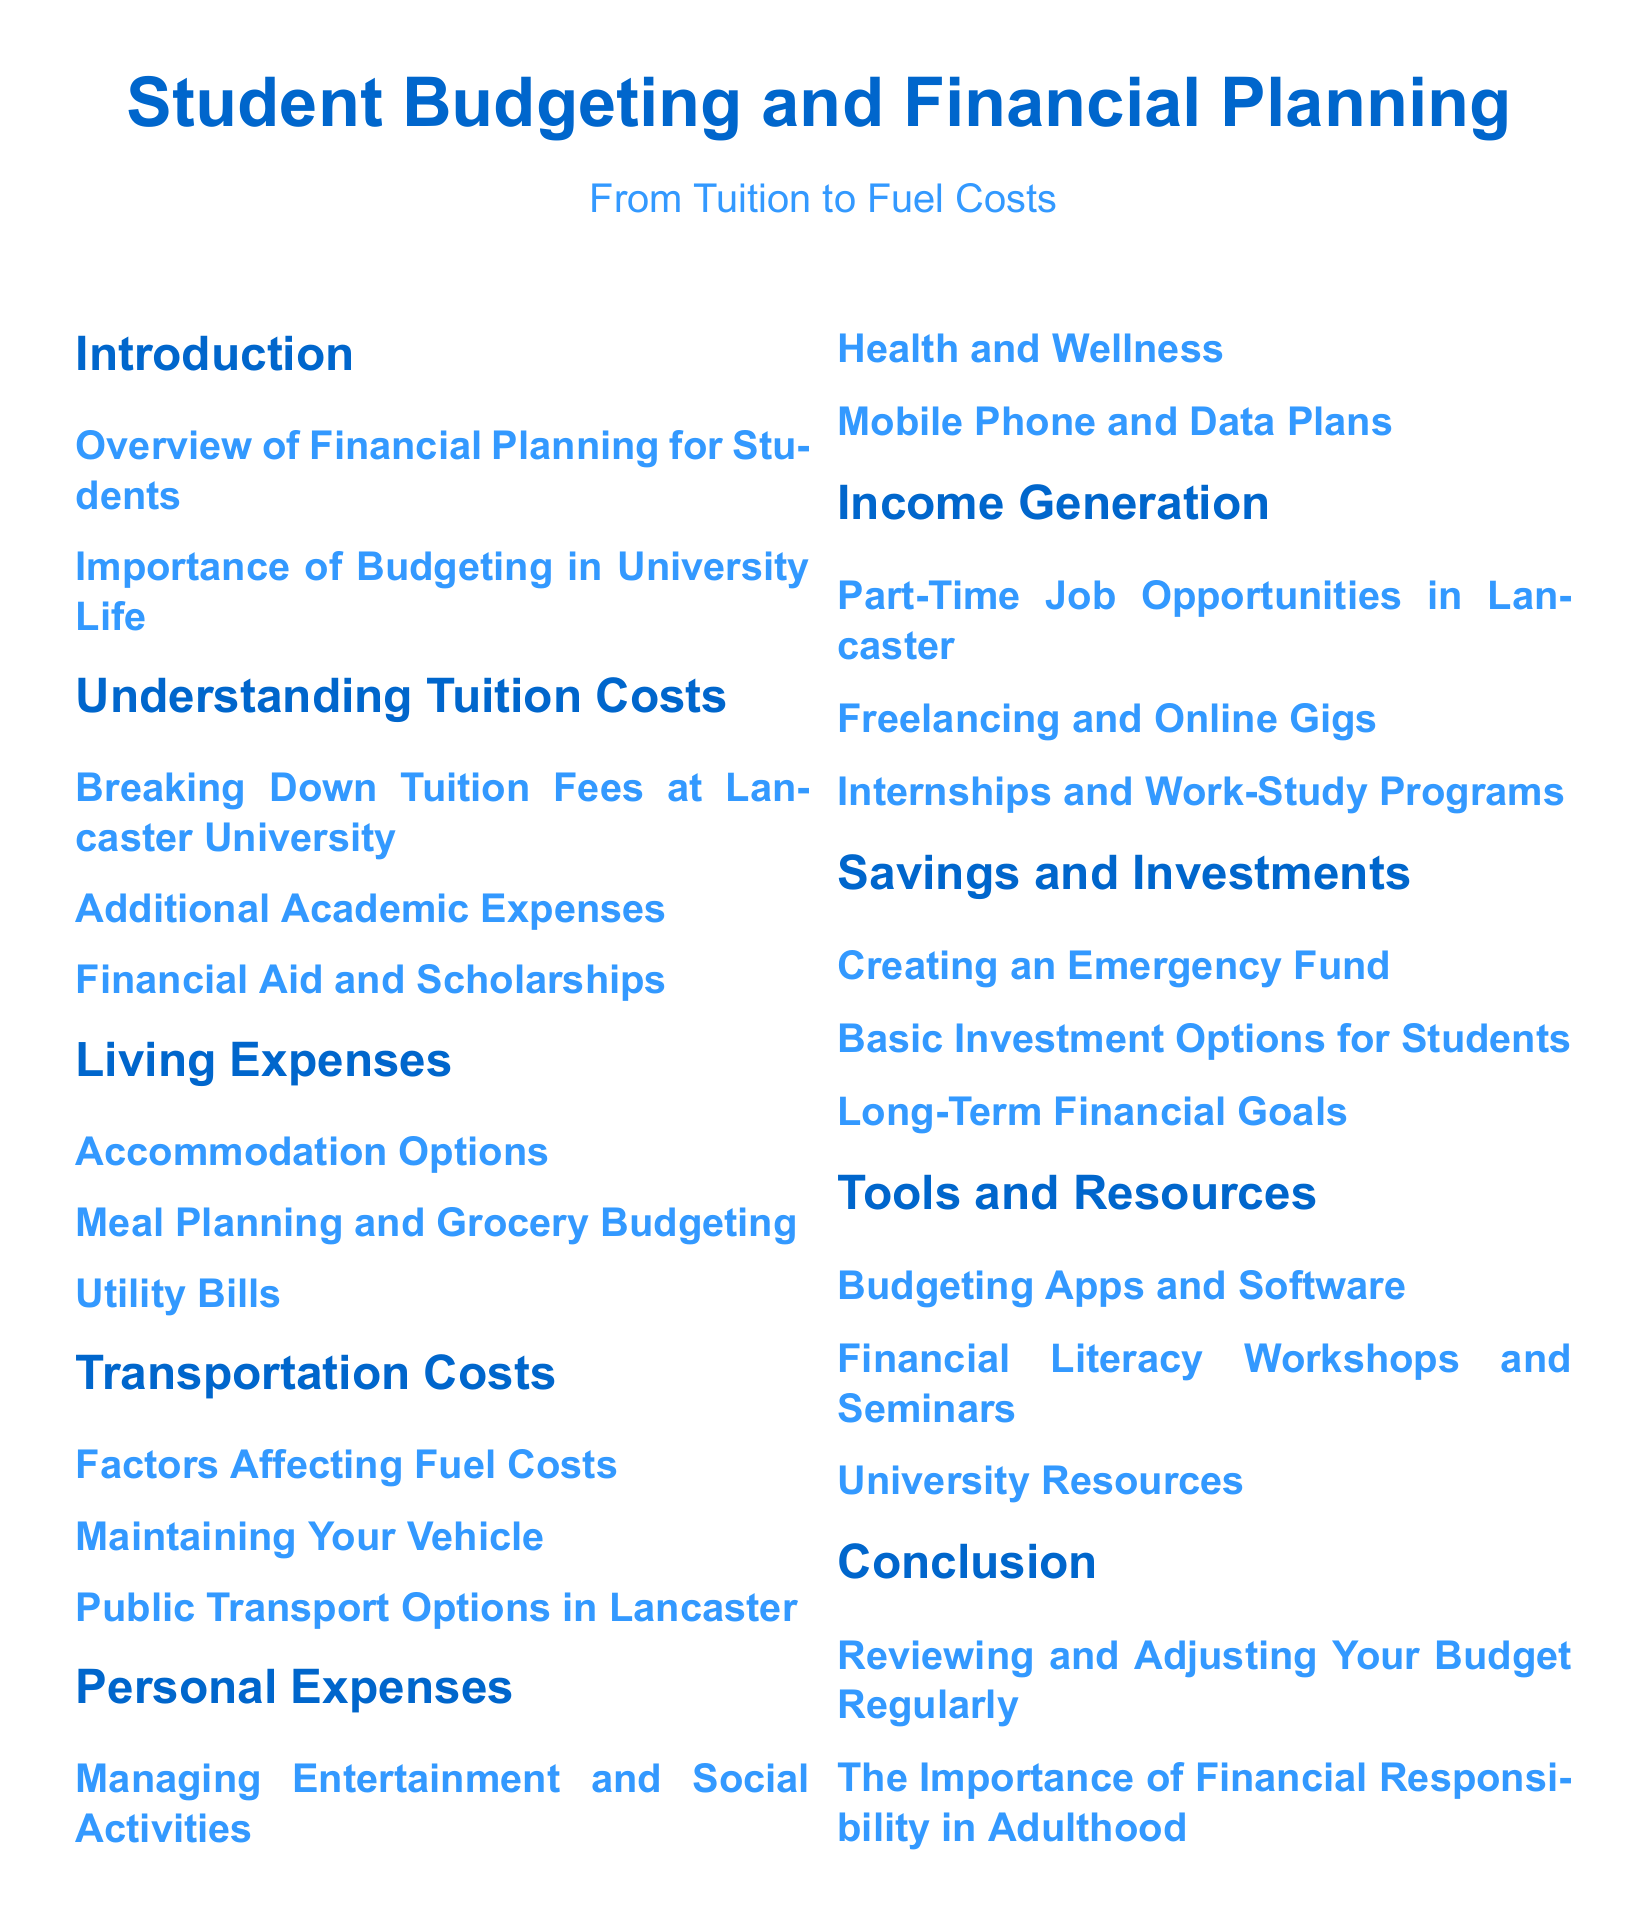What is the title of the document? The title of the document is prominently displayed at the beginning of the rendered document.
Answer: Student Budgeting and Financial Planning What is the first section in the document? The sections are numbered, and the first section follows the introduction.
Answer: Understanding Tuition Costs How many subsections are under Transportation Costs? By counting the listed subsections in the Transportation Costs section, we can determine the number.
Answer: Three What color represents the chapter titles? Colors are specified for different document elements, with chapter titles having a specific color code.
Answer: RGB(0,102,204) What type of expenses are included in Personal Expenses? The Personal Expenses section lists various types of expenses students might incur.
Answer: Entertainment and Social Activities What is emphasized in the Conclusion section? The Conclusion section contains key points about reviewing budgets and financial responsibilities.
Answer: Financial Responsibility How many options are listed under Accommodation Options? By checking the subsections, we can determine the number of options mentioned.
Answer: One What section discusses job opportunities? This section is particularly focused on income generation for students.
Answer: Income Generation What is the focus of the Tools and Resources section? This section provides various aids available to help with budgeting and financial planning.
Answer: Budgeting Apps and Software 